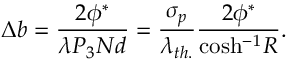Convert formula to latex. <formula><loc_0><loc_0><loc_500><loc_500>\Delta b = \frac { 2 \phi ^ { * } } { \lambda P _ { 3 } N d } = \frac { \sigma _ { p } } { \lambda _ { t h . } } \frac { { 2 } \phi ^ { * } } { \cosh ^ { - 1 } R } .</formula> 